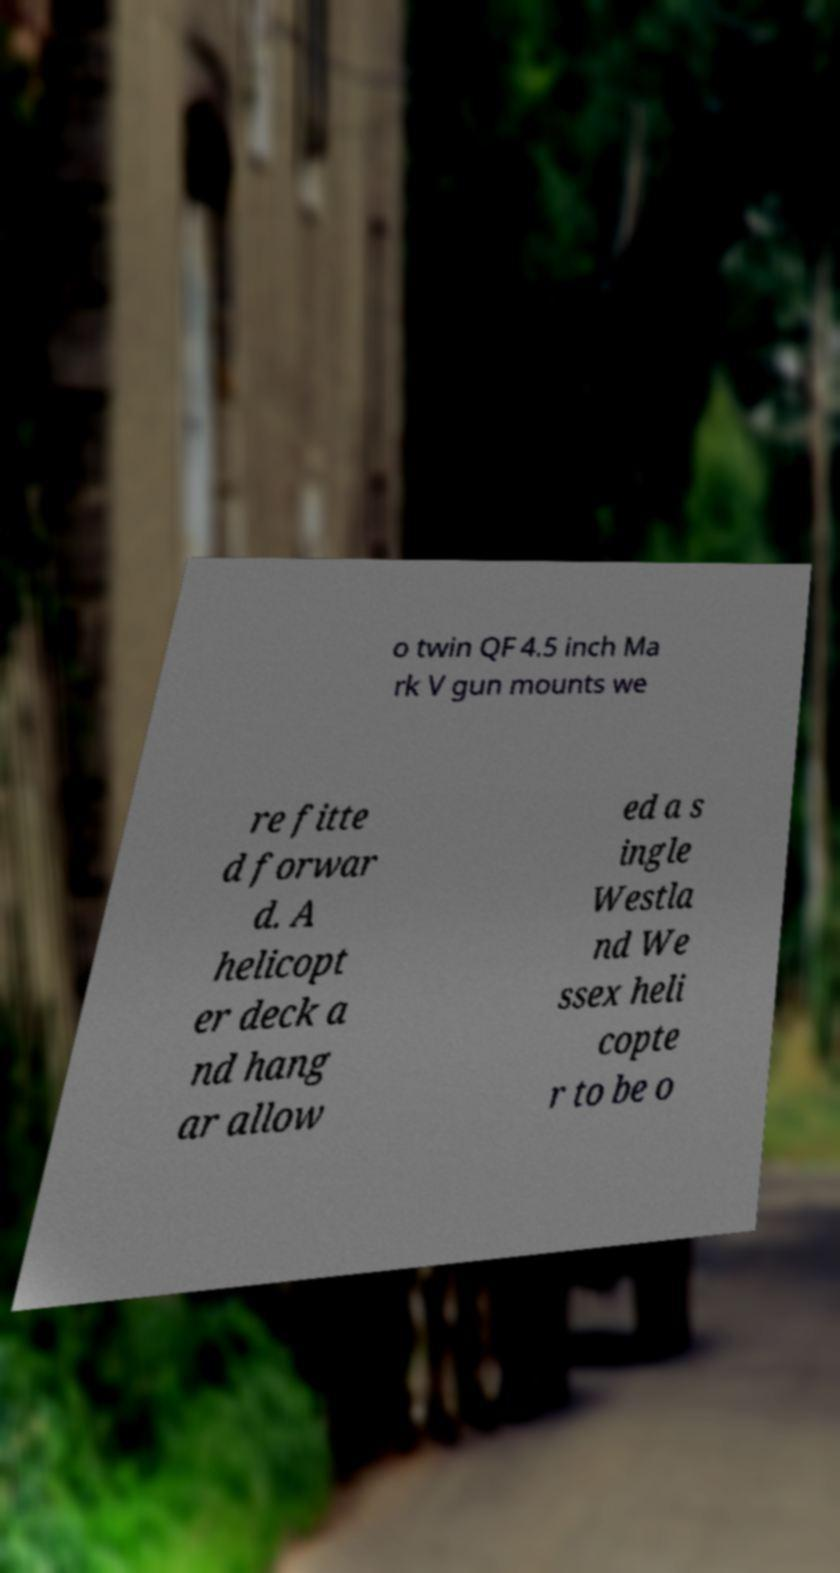I need the written content from this picture converted into text. Can you do that? o twin QF 4.5 inch Ma rk V gun mounts we re fitte d forwar d. A helicopt er deck a nd hang ar allow ed a s ingle Westla nd We ssex heli copte r to be o 